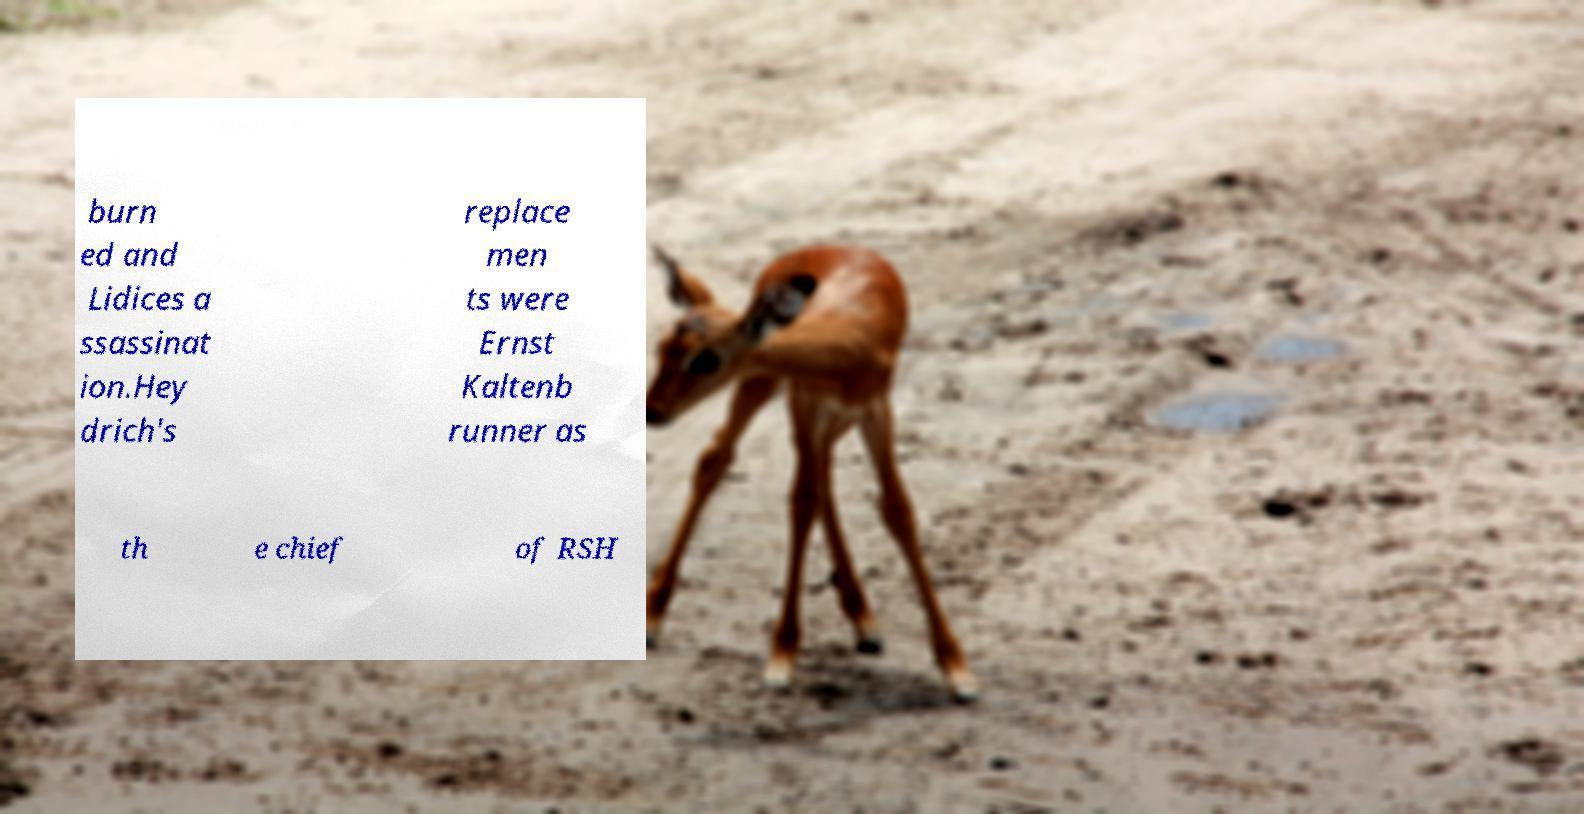What messages or text are displayed in this image? I need them in a readable, typed format. burn ed and Lidices a ssassinat ion.Hey drich's replace men ts were Ernst Kaltenb runner as th e chief of RSH 